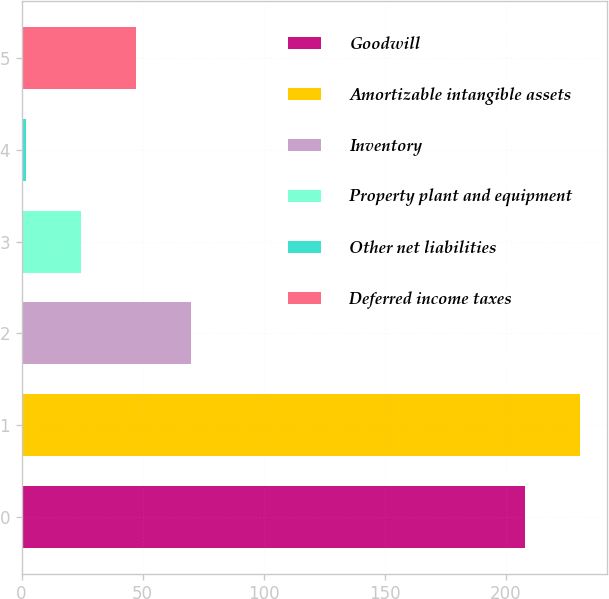Convert chart. <chart><loc_0><loc_0><loc_500><loc_500><bar_chart><fcel>Goodwill<fcel>Amortizable intangible assets<fcel>Inventory<fcel>Property plant and equipment<fcel>Other net liabilities<fcel>Deferred income taxes<nl><fcel>208<fcel>230.6<fcel>69.8<fcel>24.6<fcel>2<fcel>47.2<nl></chart> 